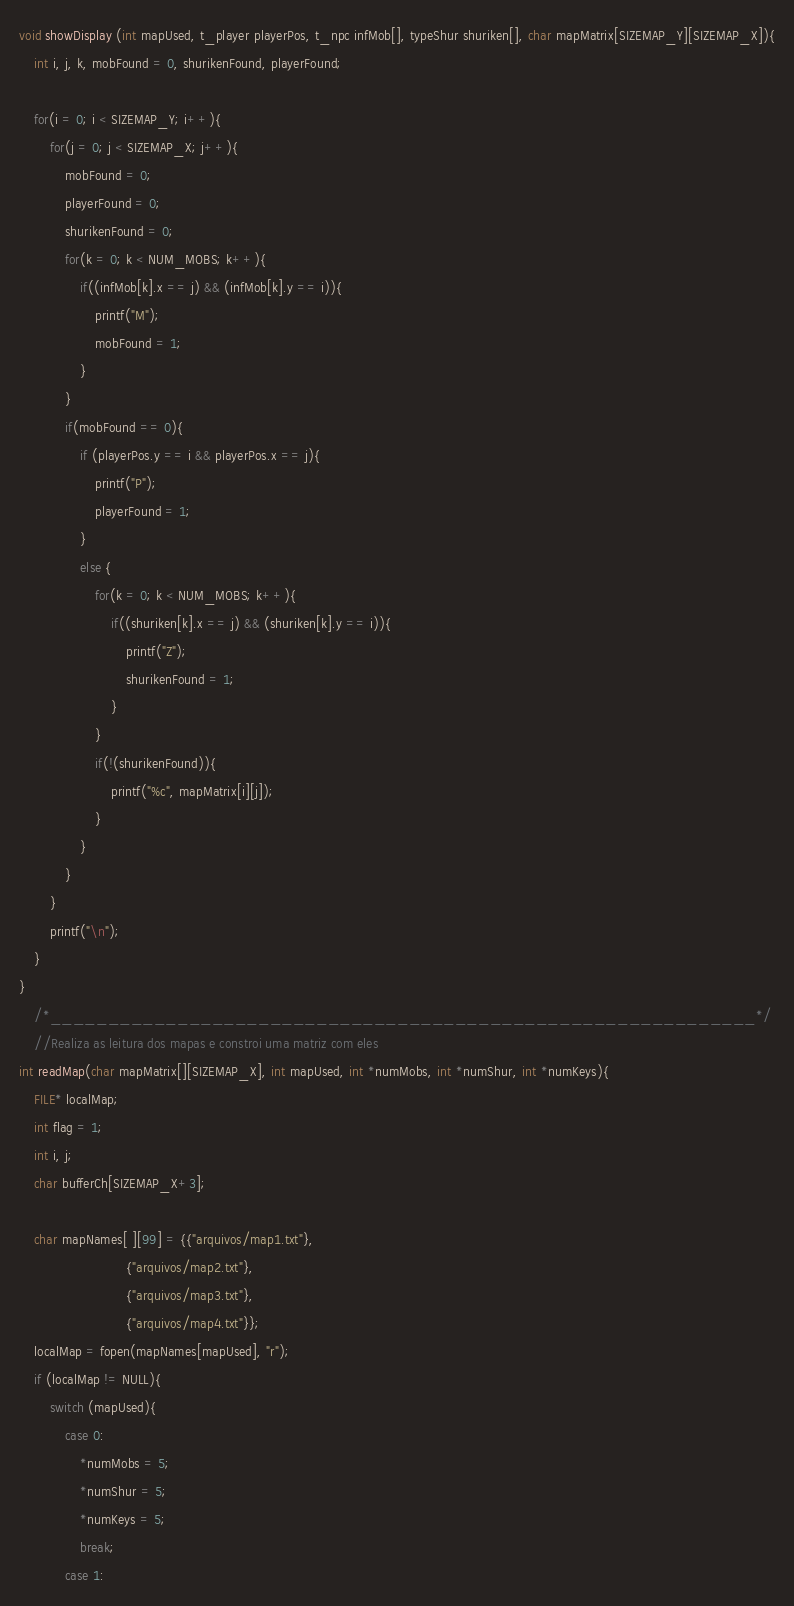<code> <loc_0><loc_0><loc_500><loc_500><_C_>void showDisplay (int mapUsed, t_player playerPos, t_npc infMob[], typeShur shuriken[], char mapMatrix[SIZEMAP_Y][SIZEMAP_X]){
    int i, j, k, mobFound = 0, shurikenFound, playerFound;

    for(i = 0; i < SIZEMAP_Y; i++){
        for(j = 0; j < SIZEMAP_X; j++){
            mobFound = 0;
            playerFound = 0;
            shurikenFound = 0;
            for(k = 0; k < NUM_MOBS; k++){
                if((infMob[k].x == j) && (infMob[k].y == i)){
                    printf("M");
                    mobFound = 1;
                }
            }
            if(mobFound == 0){
                if (playerPos.y == i && playerPos.x == j){
                    printf("P");
                    playerFound = 1;
                }
                else {
                    for(k = 0; k < NUM_MOBS; k++){
                        if((shuriken[k].x == j) && (shuriken[k].y == i)){
                            printf("Z");
                            shurikenFound = 1;
                        }
                    }
                    if(!(shurikenFound)){
                        printf("%c", mapMatrix[i][j]);
                    }
                }
            }
        }
        printf("\n");
    }
}
    /*_____________________________________________________________*/
    //Realiza as leitura dos mapas e constroi uma matriz com eles
int readMap(char mapMatrix[][SIZEMAP_X], int mapUsed, int *numMobs, int *numShur, int *numKeys){
    FILE* localMap;
    int flag = 1;
    int i, j;
    char bufferCh[SIZEMAP_X+3];

    char mapNames[ ][99] = {{"arquivos/map1.txt"},
                            {"arquivos/map2.txt"},
                            {"arquivos/map3.txt"},
                            {"arquivos/map4.txt"}};
    localMap = fopen(mapNames[mapUsed], "r");
    if (localMap != NULL){
        switch (mapUsed){
            case 0:
                *numMobs = 5;
                *numShur = 5;
                *numKeys = 5;
                break;
            case 1:</code> 